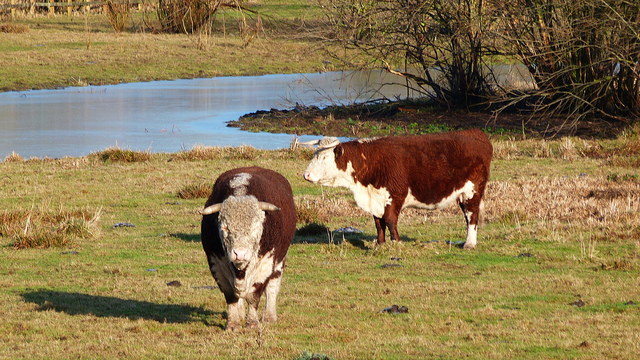Are there any indications of the cows' health or well-being from the image? From the visual cues, both cows display a robust physique with no apparent signs of distress or malnutrition. Their coats look healthy, and they seem engaged in natural behaviors such as grazing, which are positive indicators of their well-being in this environment. 